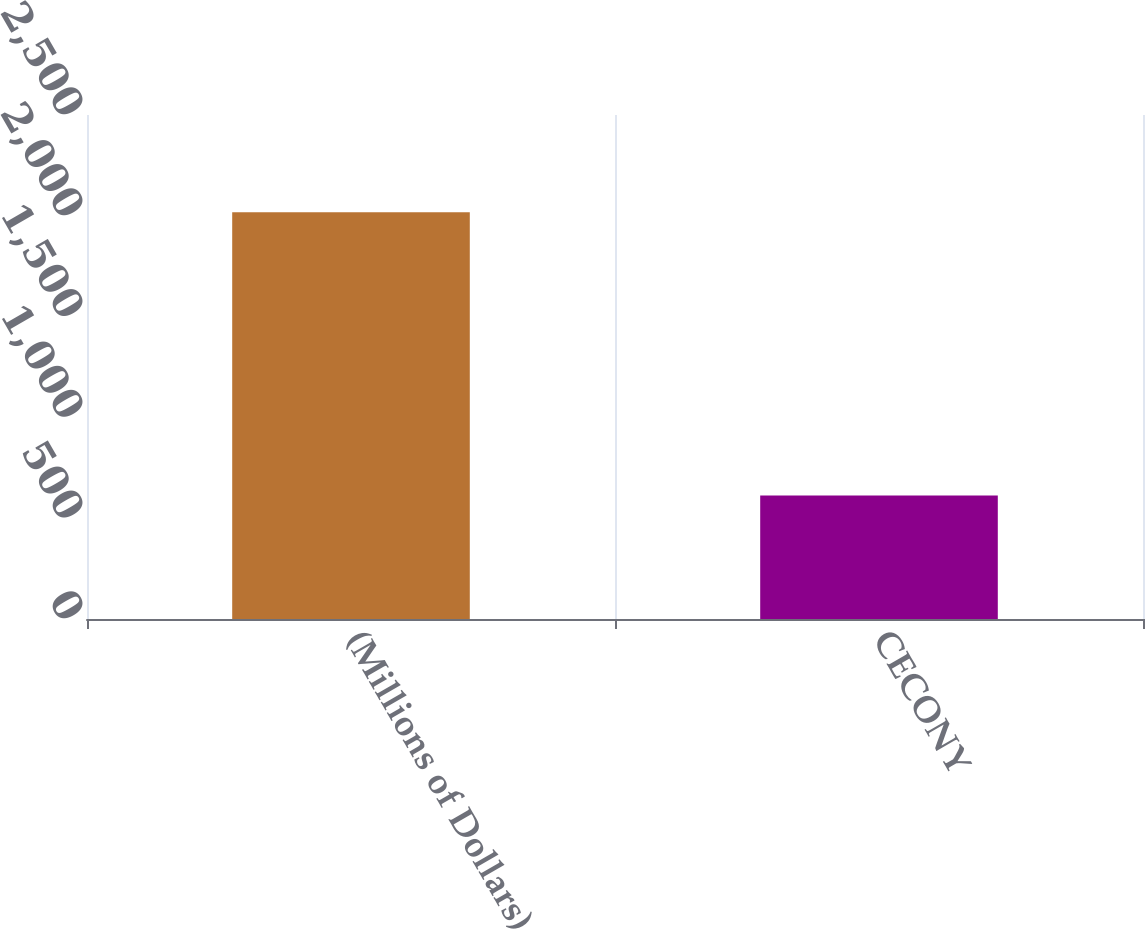Convert chart. <chart><loc_0><loc_0><loc_500><loc_500><bar_chart><fcel>(Millions of Dollars)<fcel>CECONY<nl><fcel>2018<fcel>613<nl></chart> 